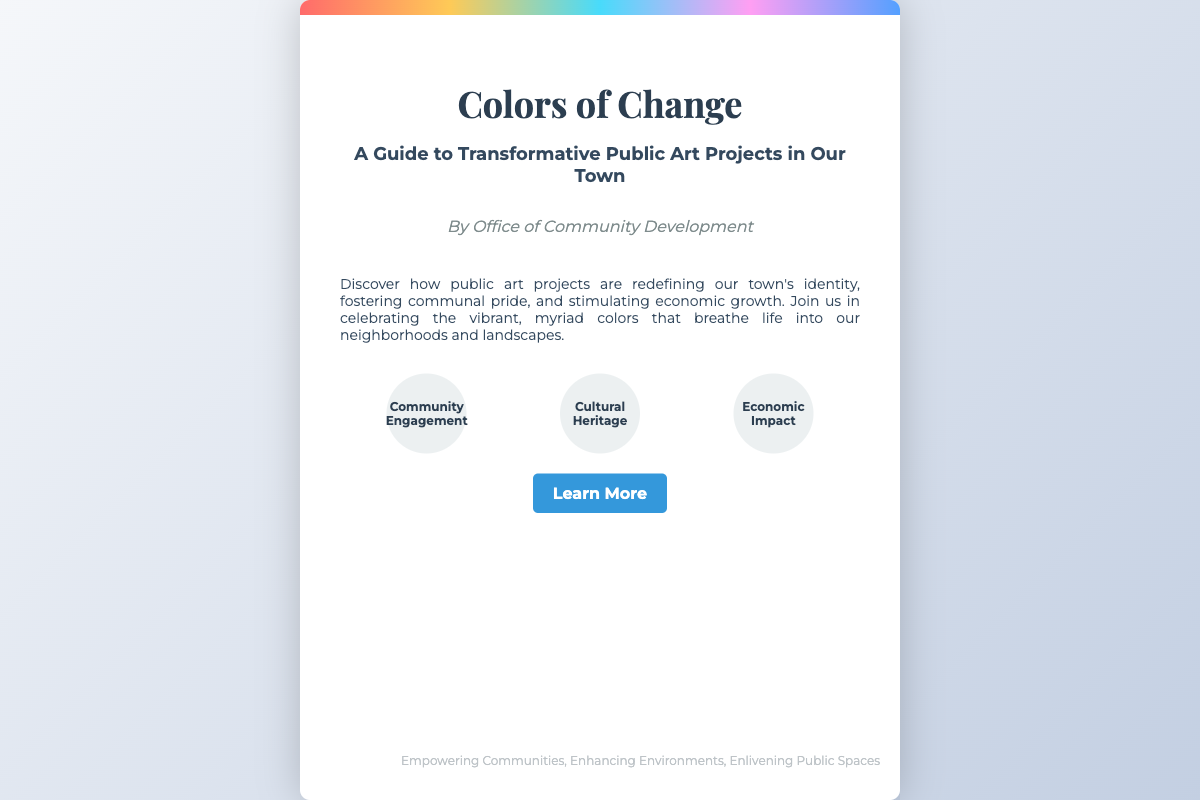what is the title of the book? The title of the book is prominently displayed at the top of the cover.
Answer: Colors of Change who is the author of the book? The author's name is mentioned below the title.
Answer: Office of Community Development what is the main theme of the book? The overview describes the primary focus of the book as it relates to public art projects.
Answer: Transformative Public Art Projects which three themes are highlighted on the cover? The themes are visually represented in circles beneath the overview.
Answer: Community Engagement, Cultural Heritage, Economic Impact what type of projects does the book guide discuss? The overview specifically mentions the types of projects discussed in the book.
Answer: Public art projects what is one purpose of the public art projects mentioned? The overview outlines a significant goal of the art projects in the community.
Answer: Fostering communal pride what does the color bar represent? The color bar is a design feature that enhances the aesthetic appeal of the book cover.
Answer: Aesthetic appeal what is the call to action on the cover? The call to action encourages readers to seek further information about the book.
Answer: Learn More 